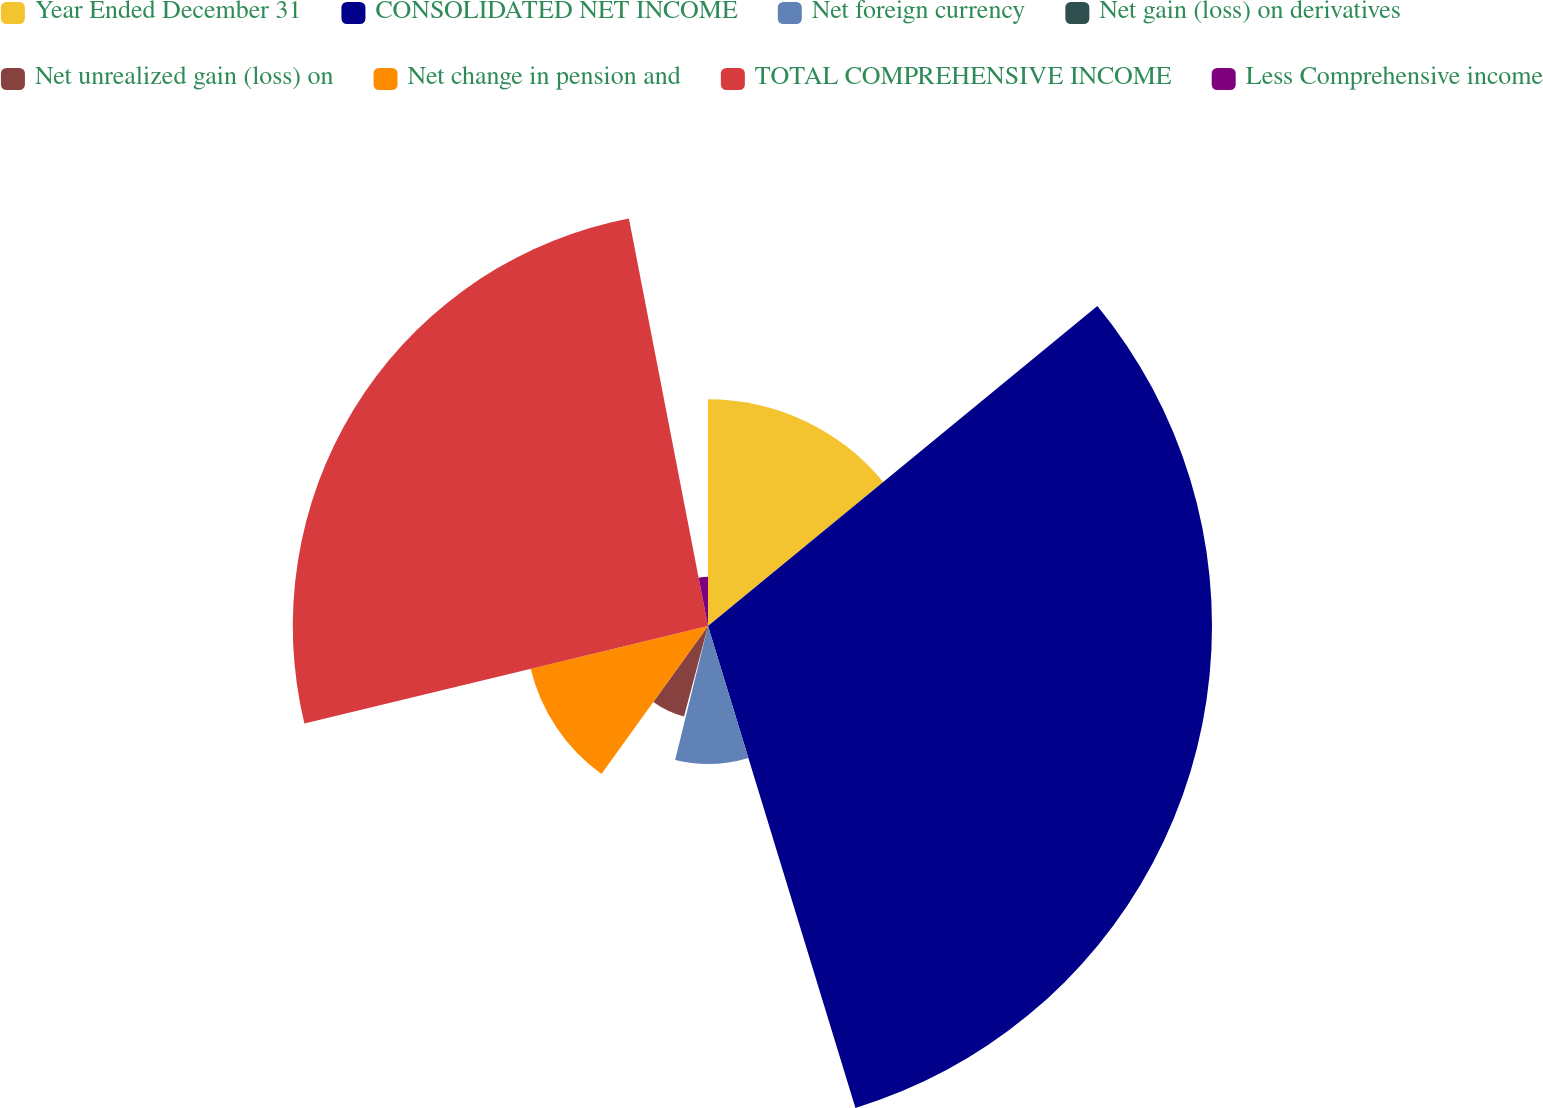Convert chart to OTSL. <chart><loc_0><loc_0><loc_500><loc_500><pie_chart><fcel>Year Ended December 31<fcel>CONSOLIDATED NET INCOME<fcel>Net foreign currency<fcel>Net gain (loss) on derivatives<fcel>Net unrealized gain (loss) on<fcel>Net change in pension and<fcel>TOTAL COMPREHENSIVE INCOME<fcel>Less Comprehensive income<nl><fcel>14.05%<fcel>31.22%<fcel>8.55%<fcel>0.3%<fcel>5.8%<fcel>11.3%<fcel>25.72%<fcel>3.05%<nl></chart> 